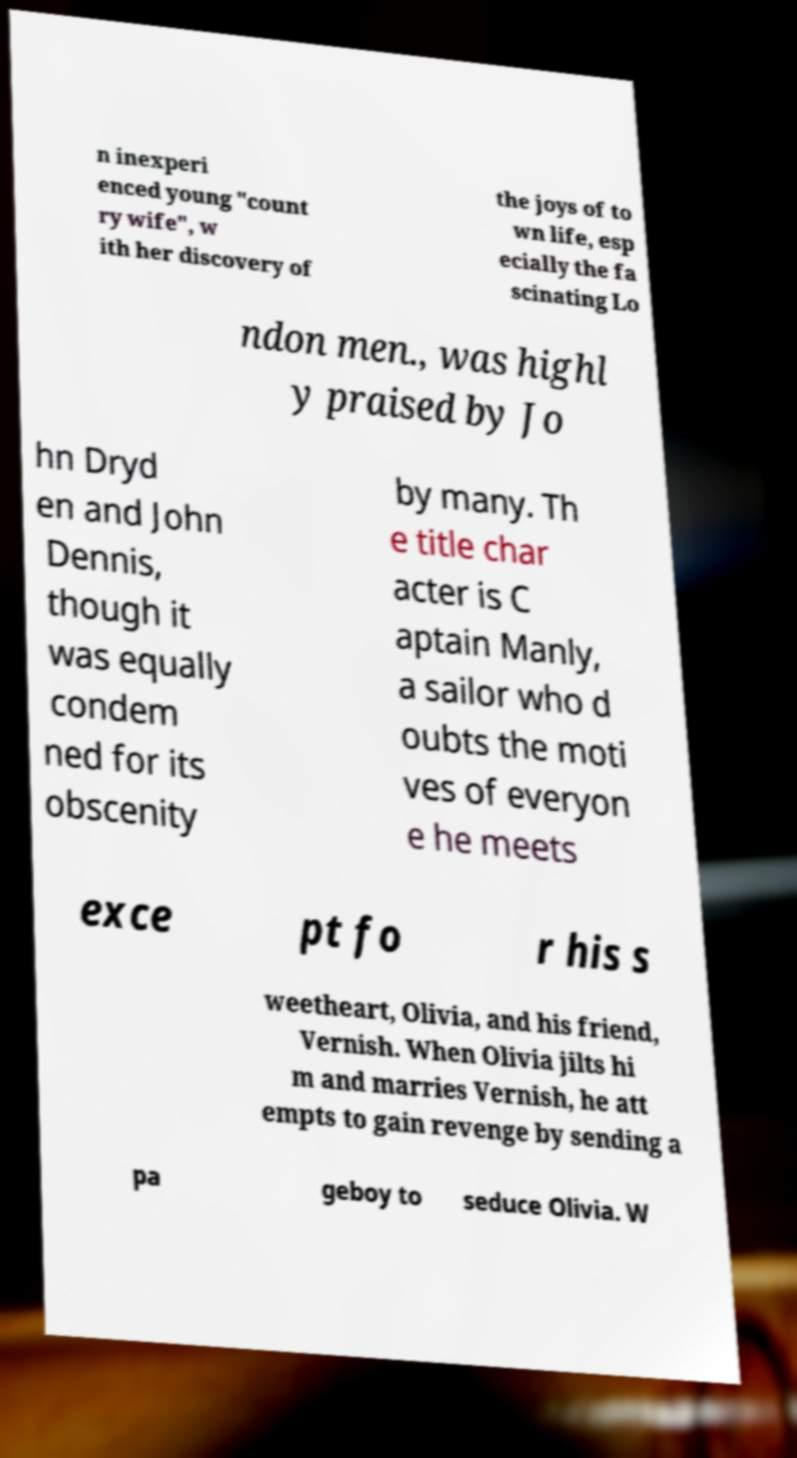Can you read and provide the text displayed in the image?This photo seems to have some interesting text. Can you extract and type it out for me? n inexperi enced young "count ry wife", w ith her discovery of the joys of to wn life, esp ecially the fa scinating Lo ndon men., was highl y praised by Jo hn Dryd en and John Dennis, though it was equally condem ned for its obscenity by many. Th e title char acter is C aptain Manly, a sailor who d oubts the moti ves of everyon e he meets exce pt fo r his s weetheart, Olivia, and his friend, Vernish. When Olivia jilts hi m and marries Vernish, he att empts to gain revenge by sending a pa geboy to seduce Olivia. W 